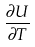<formula> <loc_0><loc_0><loc_500><loc_500>\frac { \partial U } { \partial T }</formula> 